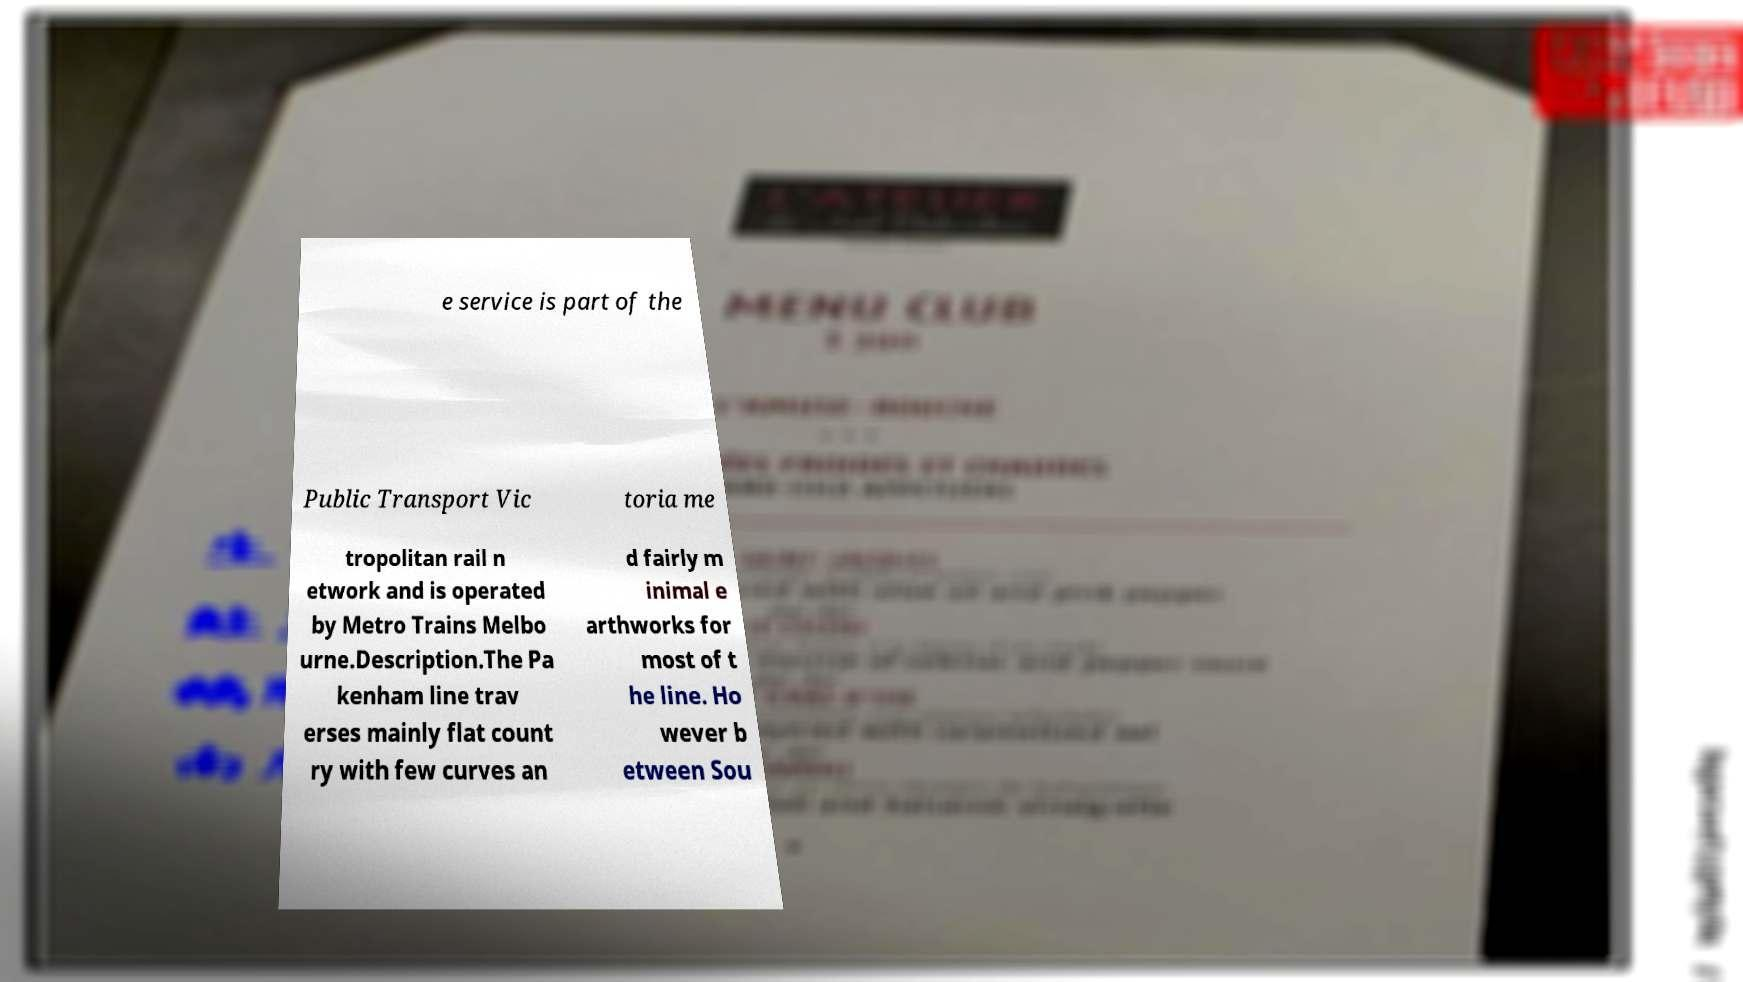Can you accurately transcribe the text from the provided image for me? e service is part of the Public Transport Vic toria me tropolitan rail n etwork and is operated by Metro Trains Melbo urne.Description.The Pa kenham line trav erses mainly flat count ry with few curves an d fairly m inimal e arthworks for most of t he line. Ho wever b etween Sou 